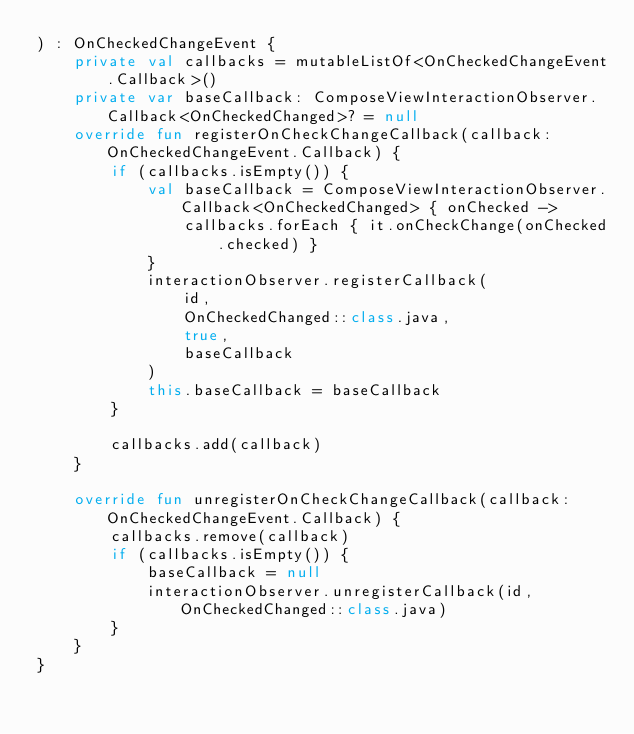Convert code to text. <code><loc_0><loc_0><loc_500><loc_500><_Kotlin_>) : OnCheckedChangeEvent {
    private val callbacks = mutableListOf<OnCheckedChangeEvent.Callback>()
    private var baseCallback: ComposeViewInteractionObserver.Callback<OnCheckedChanged>? = null
    override fun registerOnCheckChangeCallback(callback: OnCheckedChangeEvent.Callback) {
        if (callbacks.isEmpty()) {
            val baseCallback = ComposeViewInteractionObserver.Callback<OnCheckedChanged> { onChecked ->
                callbacks.forEach { it.onCheckChange(onChecked.checked) }
            }
            interactionObserver.registerCallback(
                id,
                OnCheckedChanged::class.java,
                true,
                baseCallback
            )
            this.baseCallback = baseCallback
        }

        callbacks.add(callback)
    }

    override fun unregisterOnCheckChangeCallback(callback: OnCheckedChangeEvent.Callback) {
        callbacks.remove(callback)
        if (callbacks.isEmpty()) {
            baseCallback = null
            interactionObserver.unregisterCallback(id, OnCheckedChanged::class.java)
        }
    }
}</code> 